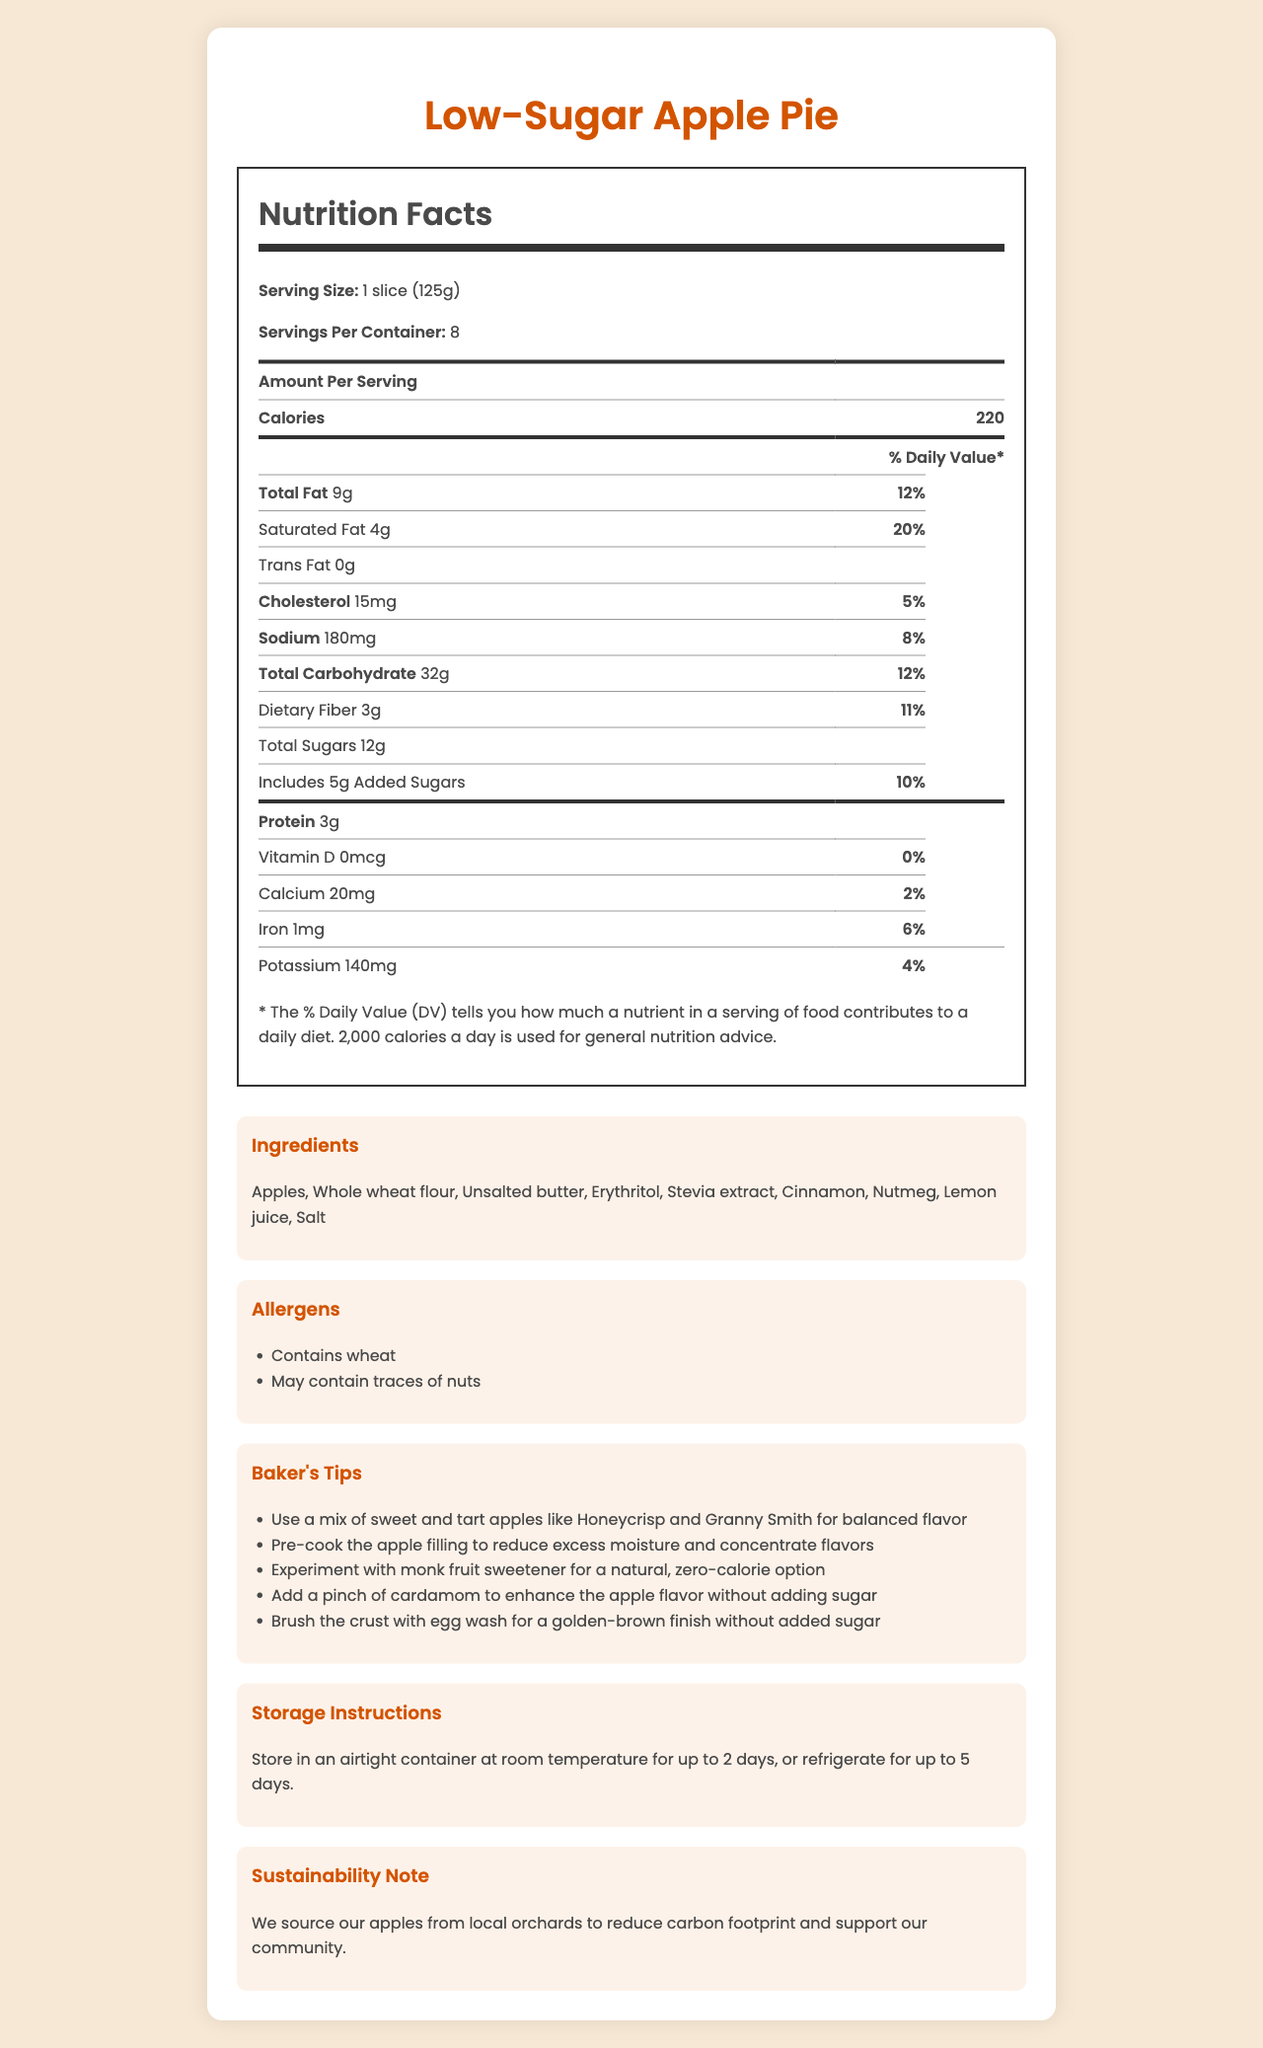what is the serving size of the low-sugar apple pie? The serving size is explicitly mentioned in the nutrition facts section as "1 slice (125g)".
Answer: 1 slice (125g) how many servings are there per container? The document states that there are 8 servings per container.
Answer: 8 how many calories does one serving of the apple pie contain? The number of calories per serving is listed as 220 in the nutrition facts.
Answer: 220 how much saturated fat is in one serving? The amount of saturated fat per serving is shown as 4g.
Answer: 4g how much added sugars are there per serving? The nutrition facts specify that there are 5g of added sugars per serving.
Answer: 5g what sweeteners are used in this apple pie? The ingredients list includes erythritol and stevia extract as sweeteners.
Answer: Erythritol and Stevia extract what is the suggestion for brushing the crust? A. Butter B. Milk C. Egg wash D. Water The baker's tips mention brushing the crust with egg wash for a golden-brown finish.
Answer: C. Egg wash which of the following is the primary source of sweetness in the recipe? A. Sugar B. Honey C. Erythritol D. Agave syrup The ingredients list includes erythritol as a sweetener instead of sugar, honey, or agave syrup.
Answer: C. Erythritol is there any trans fat in this apple pie? The nutrition facts indicate that the amount of trans fat is 0g.
Answer: No are there any allergens listed? The allergens section lists "Contains wheat" and "May contain traces of nuts".
Answer: Yes summarize the entire document The document provides a comprehensive overview of the nutritional content, ingredients, allergen information, baking tips, storage recommendations, and a sustainability note regarding the low-sugar apple pie.
Answer: The document describes the nutrition facts, ingredients, allergens, baking tips, storage instructions, and sustainability note for a low-sugar apple pie. The pie is served in 125g slices, with each serving containing 220 calories, 9g of total fat, and 12g of sugars, including 5g of added sugars. The pie uses alternative sweeteners like erythritol and stevia, and it includes tips for enhancing flavor without adding sugar. It can be stored at room temperature or refrigerated, and the apples are locally sourced. how can you enhance the apple flavor without adding sugar? The baker's tips suggest adding a pinch of cardamom to enhance the apple flavor without adding sugar.
Answer: Add a pinch of cardamom what is the source of protein in the pie? The document does not specify the exact source of protein within the ingredient list.
Answer: Not enough information which mineral is present in the greatest amount per serving? A. Calcium B. Iron C. Potassium The nutrition facts show that Iron is 1mg (6% DV), Calcium is 20mg (2% DV), and Potassium is 140mg (4% DV), so Iron has the highest daily value percentage.
Answer: B. Iron should the apple filling be pre-cooked? The baker's tips recommend pre-cooking the apple filling to reduce excess moisture and concentrate flavors.
Answer: Yes how much sodium is in one serving? The nutrition facts list the sodium amount as 180mg per serving.
Answer: 180mg where are the apples sourced from? The sustainability note mentions that the apples are sourced from local orchards to reduce carbon footprint and support the community.
Answer: Local orchards for how long can the pie be stored at room temperature? The storage instructions indicate that the pie can be stored in an airtight container at room temperature for up to 2 days.
Answer: Up to 2 days 